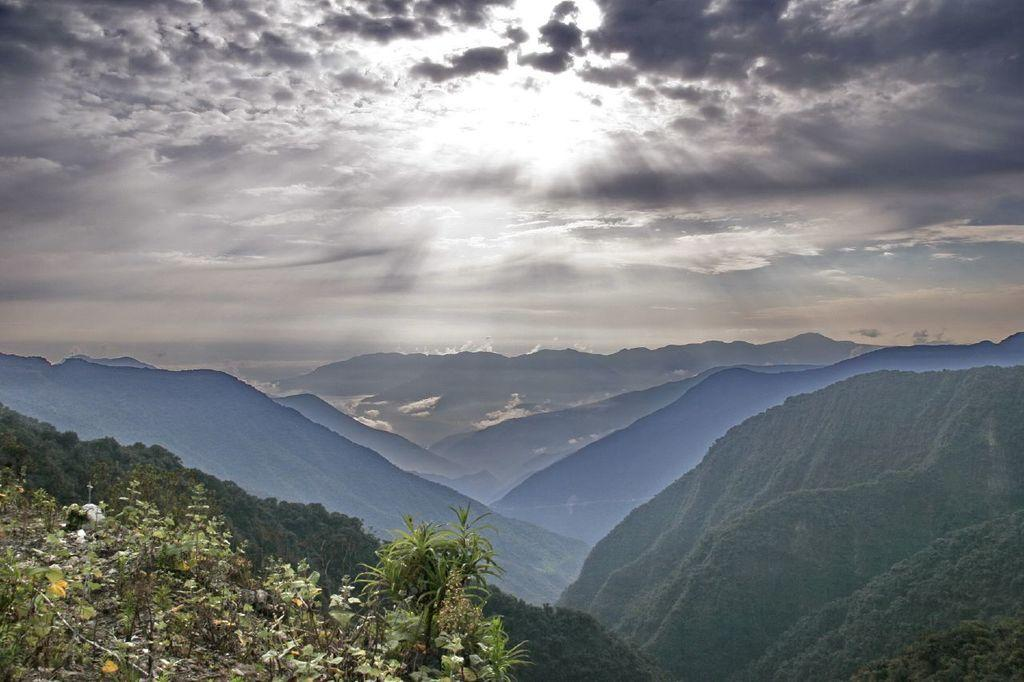What type of view is shown in the image? The image has an outside view. What can be seen in the foreground of the image? There are hills in the foreground of the image. What is visible in the background of the image? The sky is visible in the background of the image. What color is the orange on the roof in the image? There is no orange or roof present in the image. 